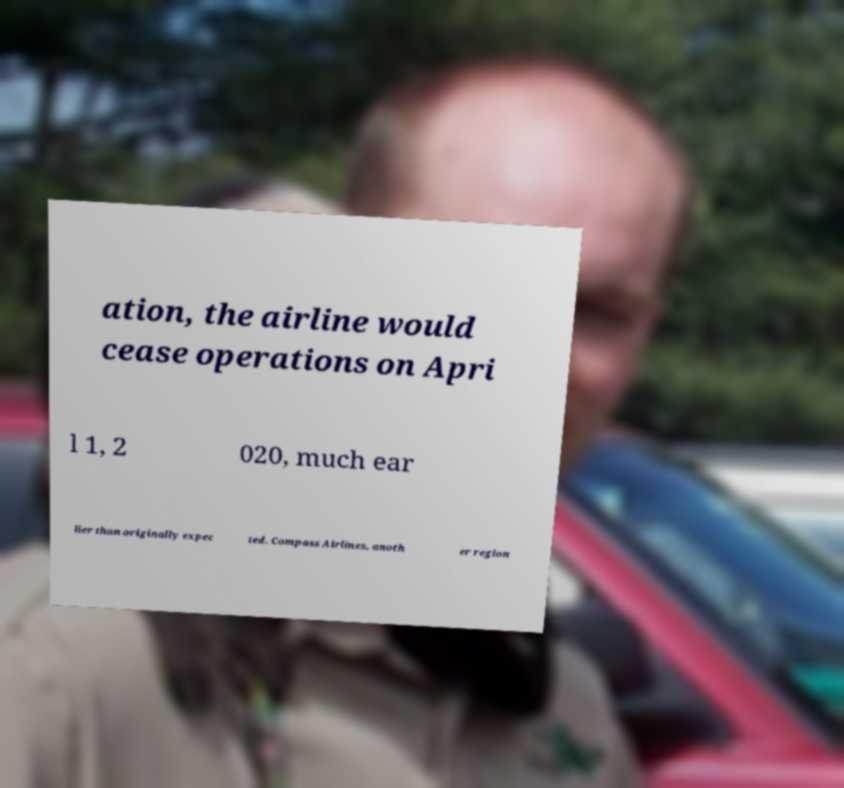I need the written content from this picture converted into text. Can you do that? ation, the airline would cease operations on Apri l 1, 2 020, much ear lier than originally expec ted. Compass Airlines, anoth er region 